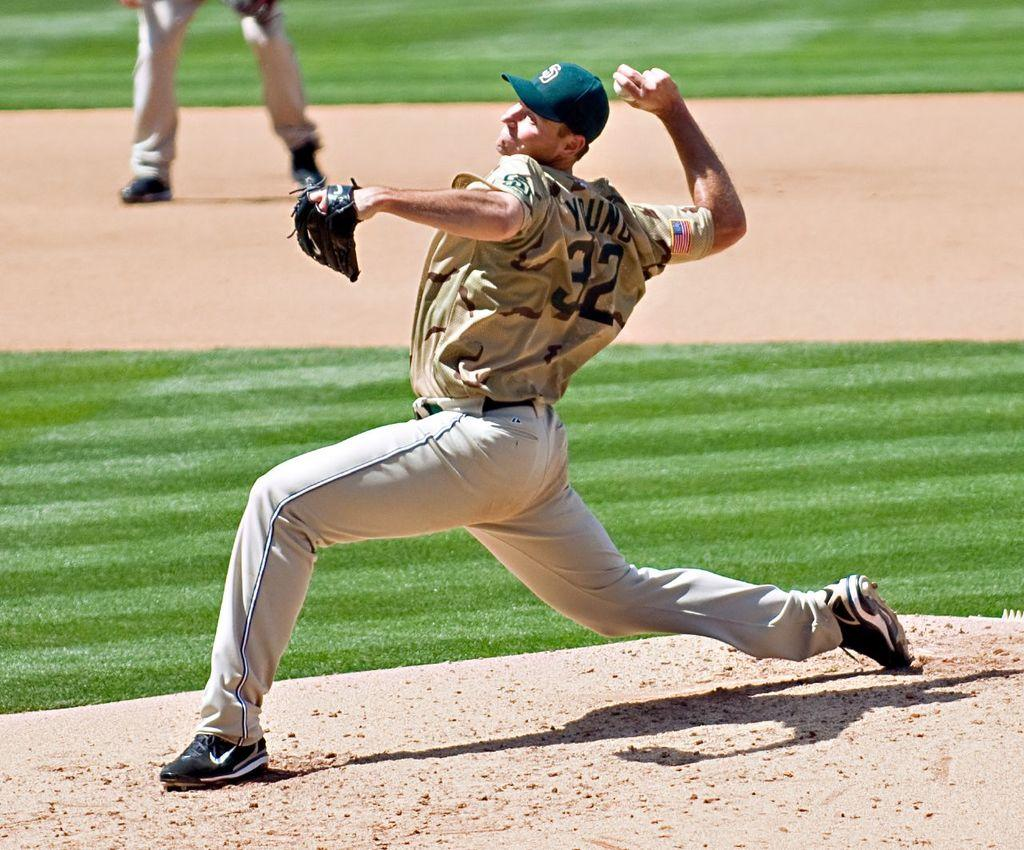What is the main subject of the image? There is a man in the image. What is the man doing in the image? The man might be standing, and he is holding a ball. Can you describe the person behind the man? There is a person standing at the back of the man. What type of surface is visible at the bottom of the image? There is grass at the bottom of the image, and there is ground visible in the image. What type of soda is the man drinking in the image? There is no soda present in the image; the man is holding a ball. How does the man maintain his balance while holding the ball in the image? The image does not provide information about the man's balance, but he might be standing still while holding the ball. 